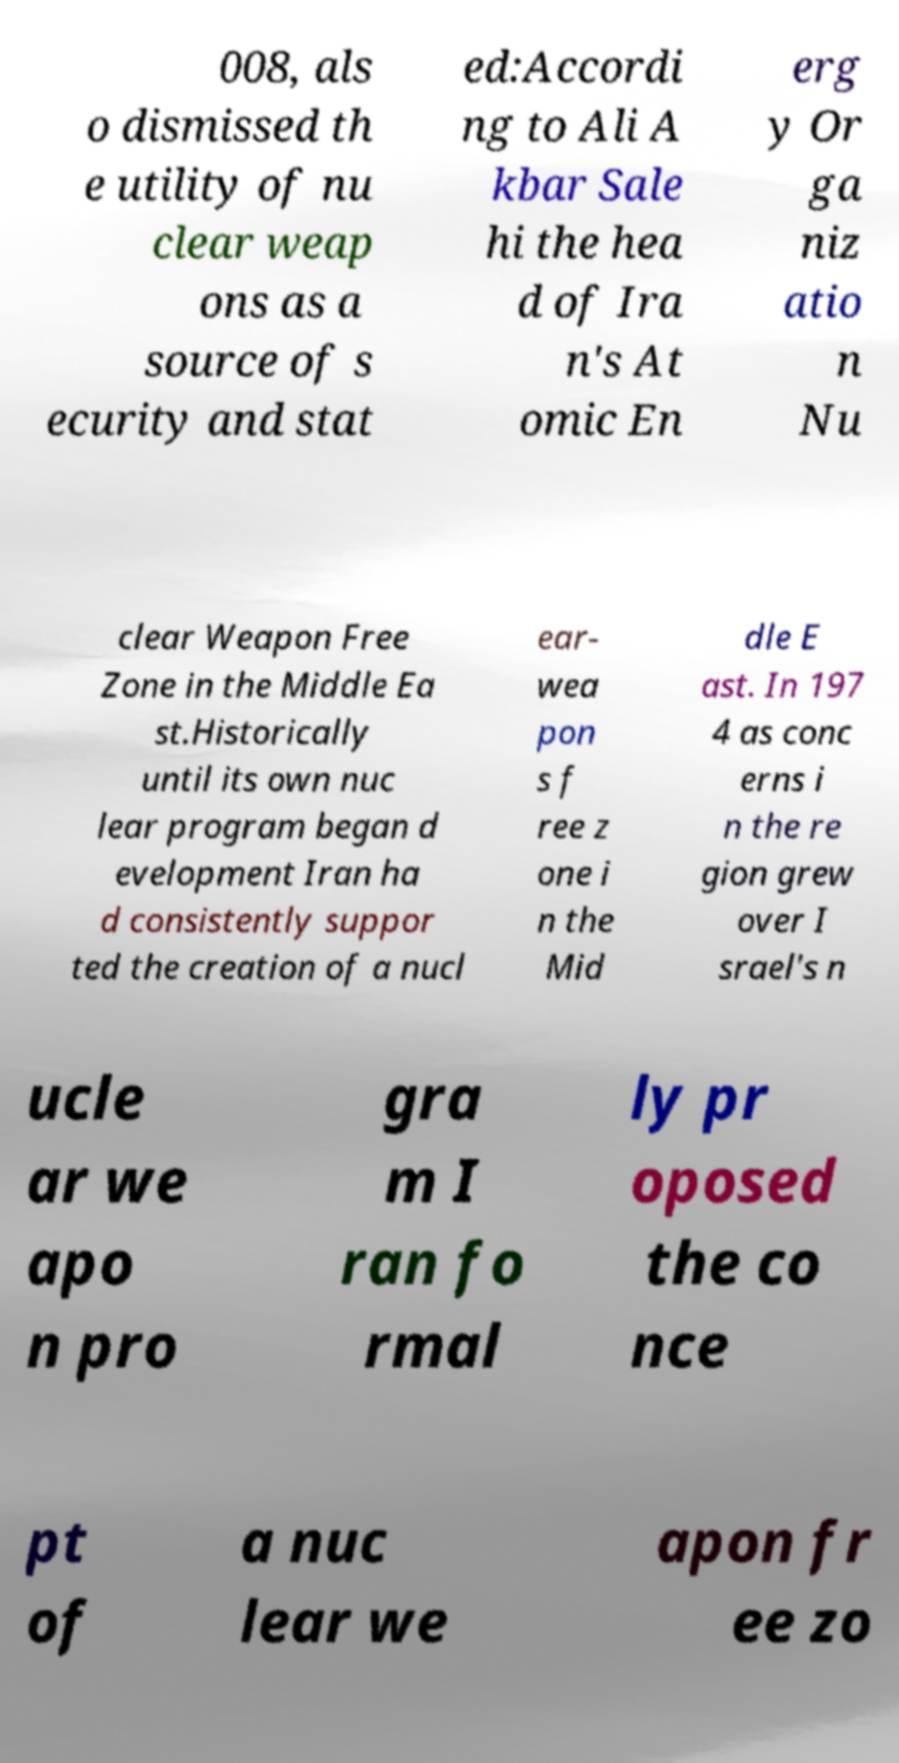I need the written content from this picture converted into text. Can you do that? 008, als o dismissed th e utility of nu clear weap ons as a source of s ecurity and stat ed:Accordi ng to Ali A kbar Sale hi the hea d of Ira n's At omic En erg y Or ga niz atio n Nu clear Weapon Free Zone in the Middle Ea st.Historically until its own nuc lear program began d evelopment Iran ha d consistently suppor ted the creation of a nucl ear- wea pon s f ree z one i n the Mid dle E ast. In 197 4 as conc erns i n the re gion grew over I srael's n ucle ar we apo n pro gra m I ran fo rmal ly pr oposed the co nce pt of a nuc lear we apon fr ee zo 